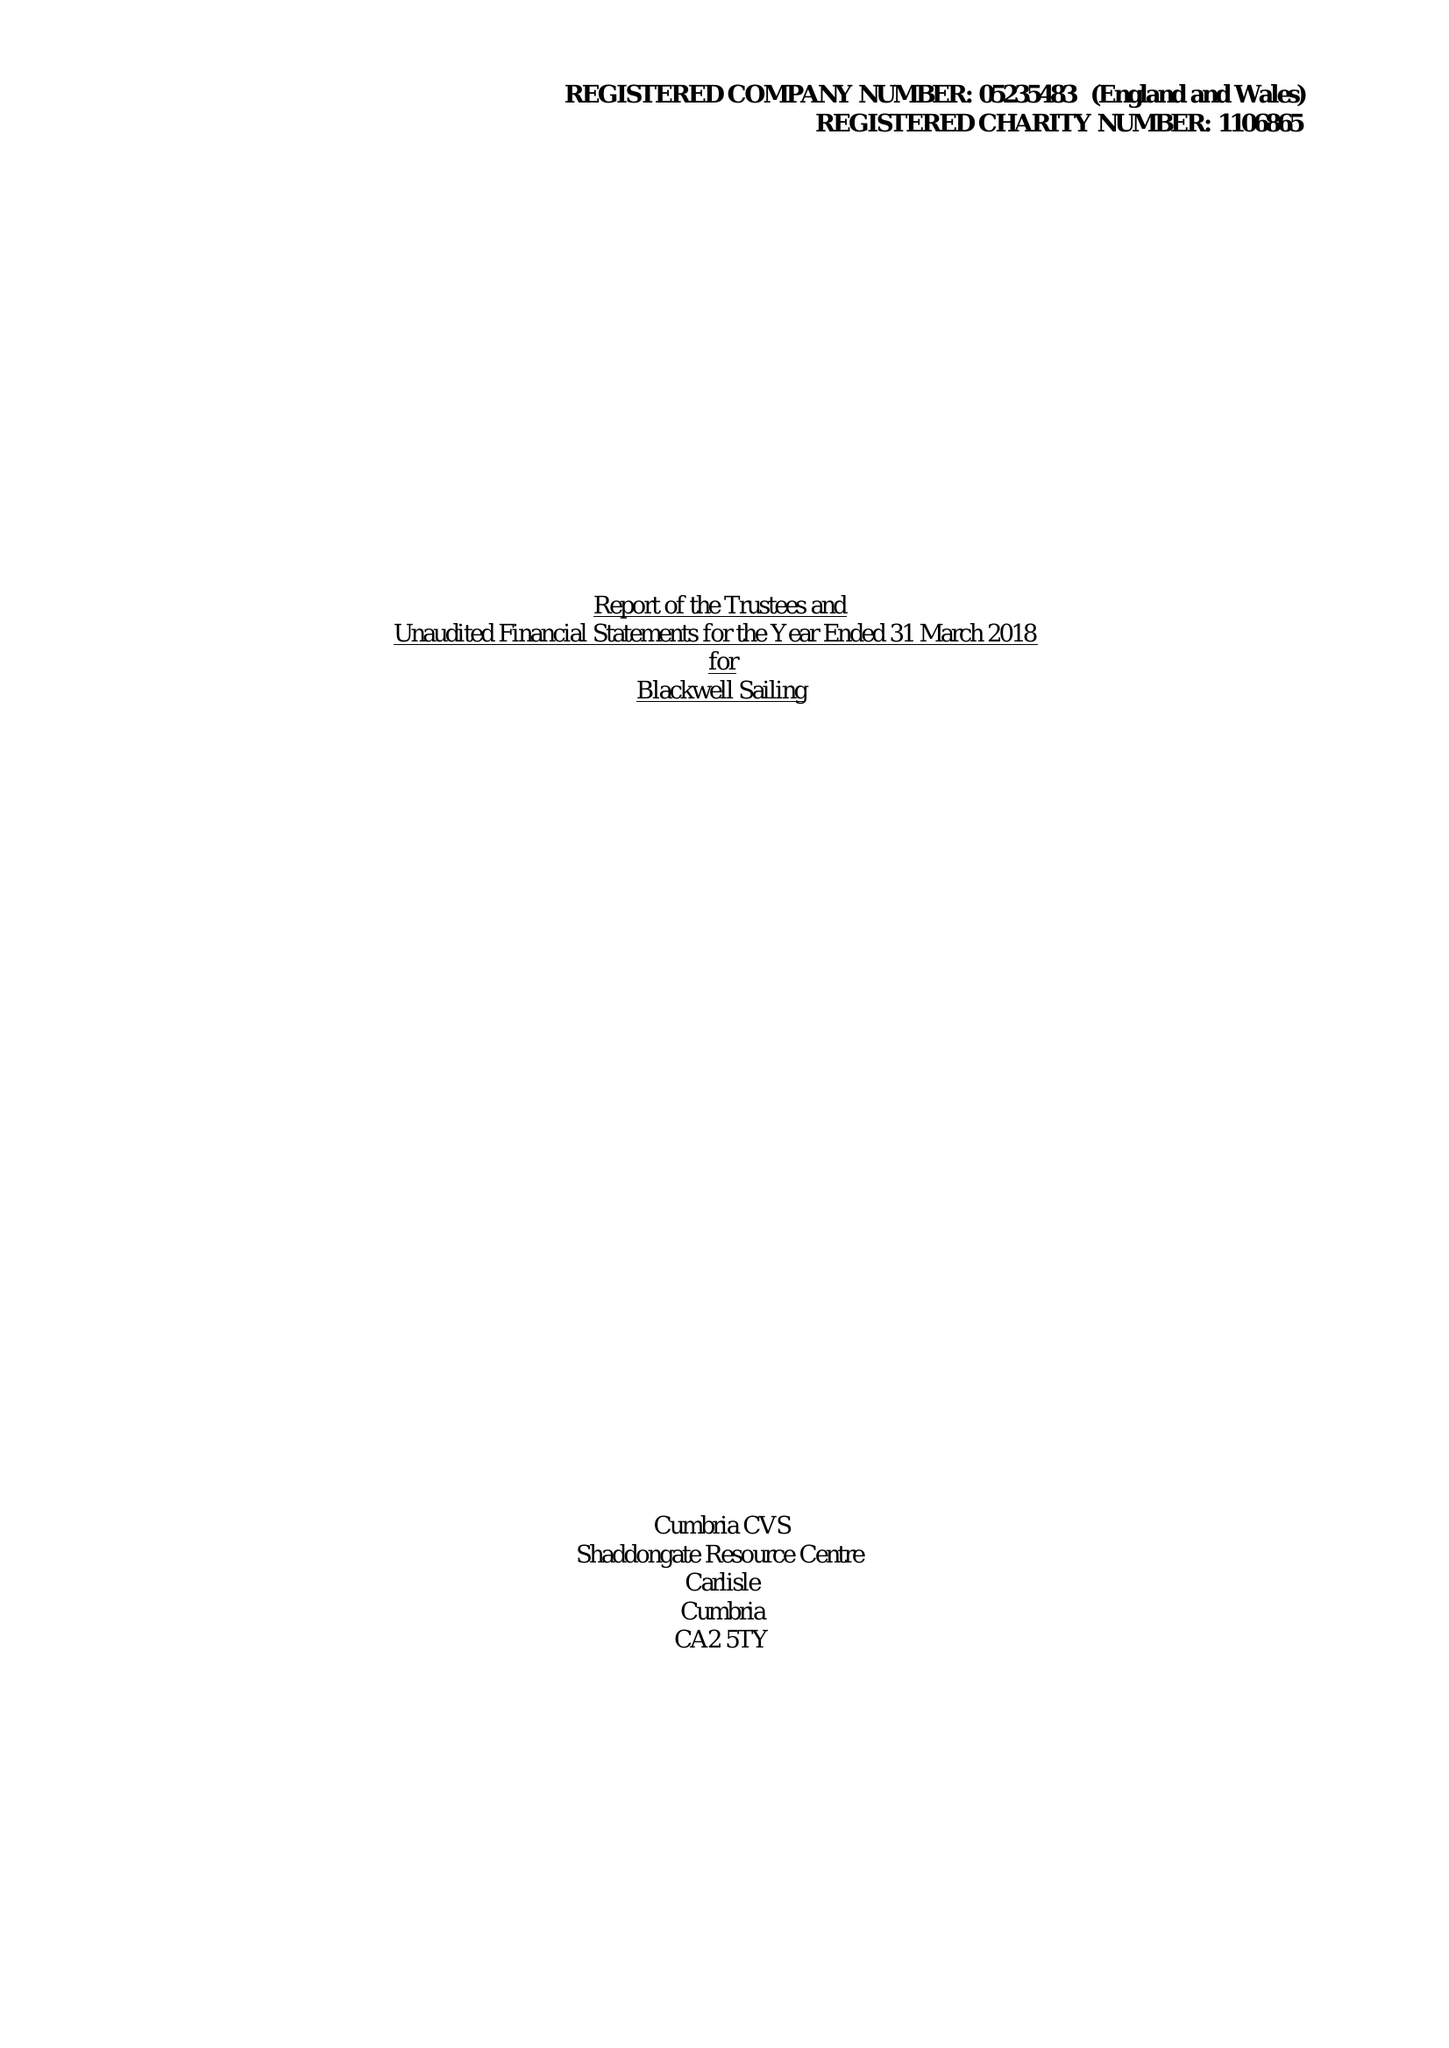What is the value for the address__post_town?
Answer the question using a single word or phrase. WINDERMERE 